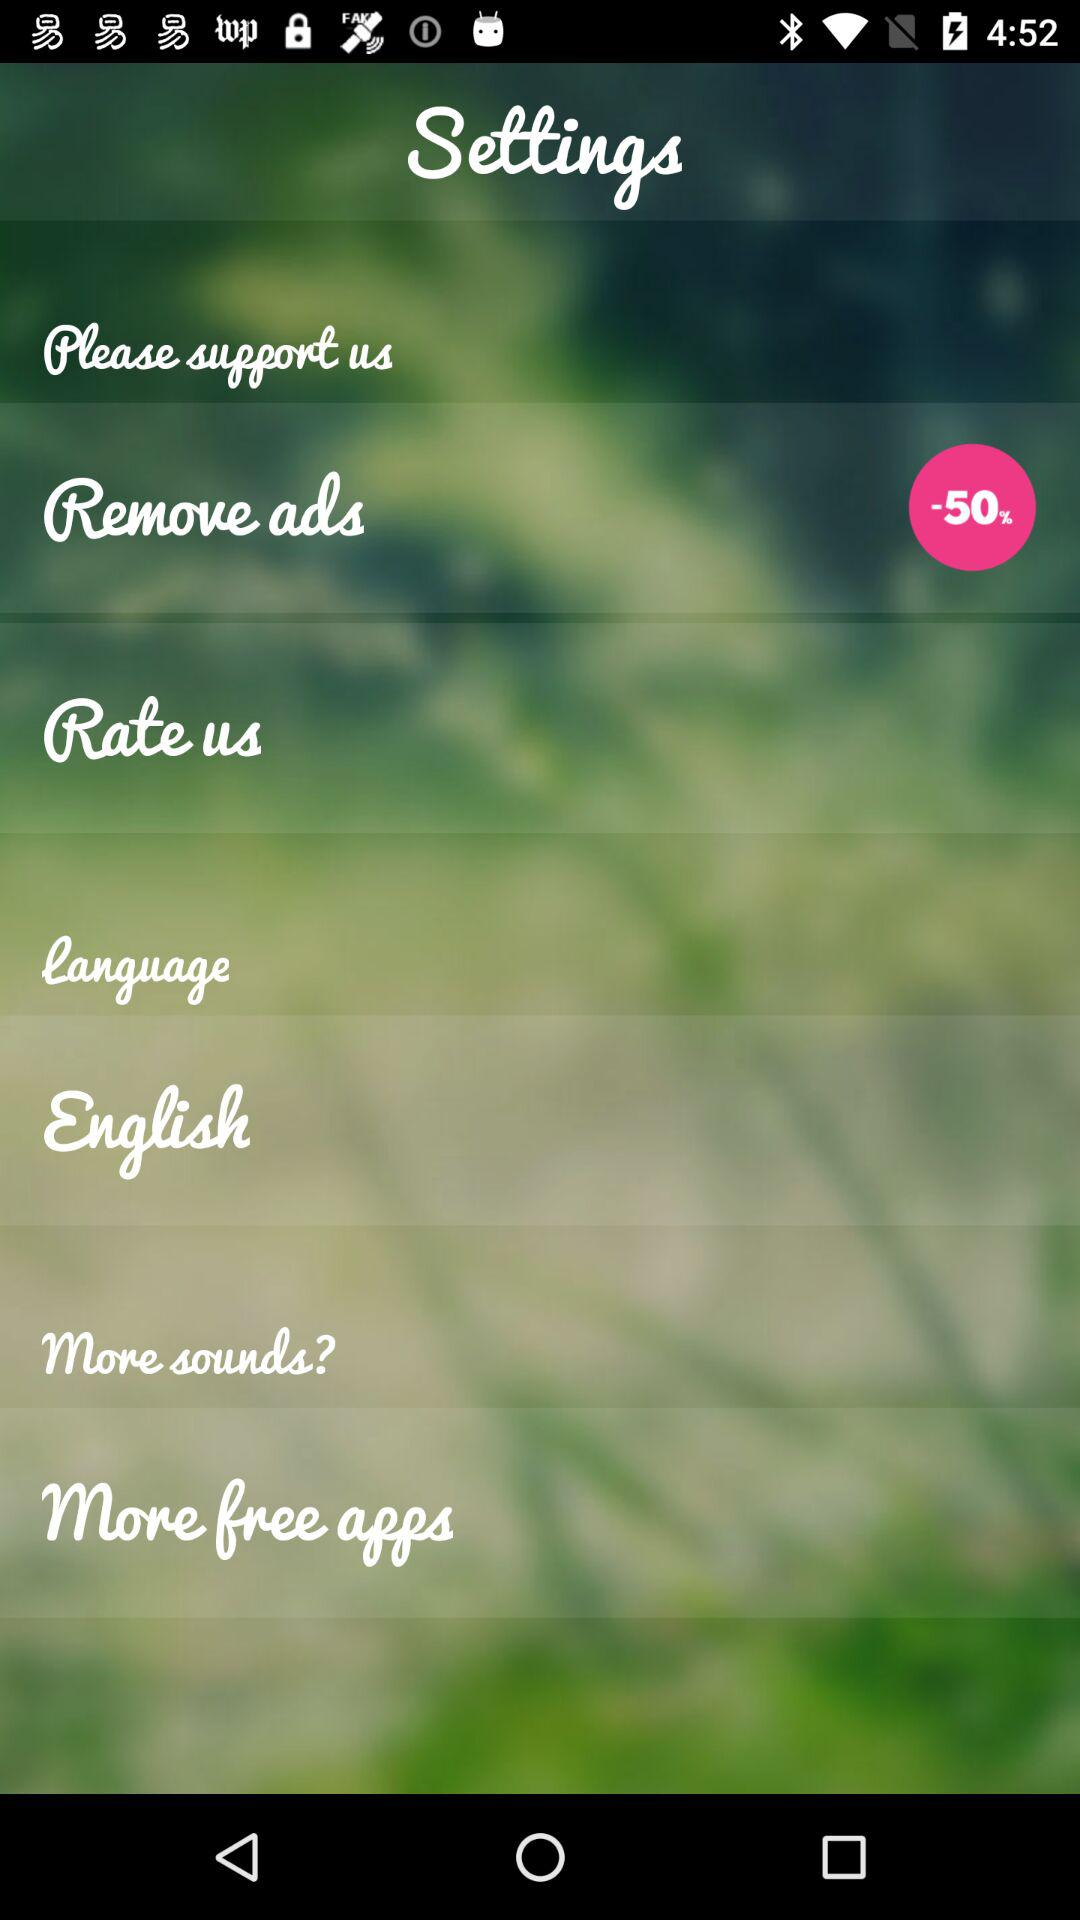What is the selected language? The selected language is English. 